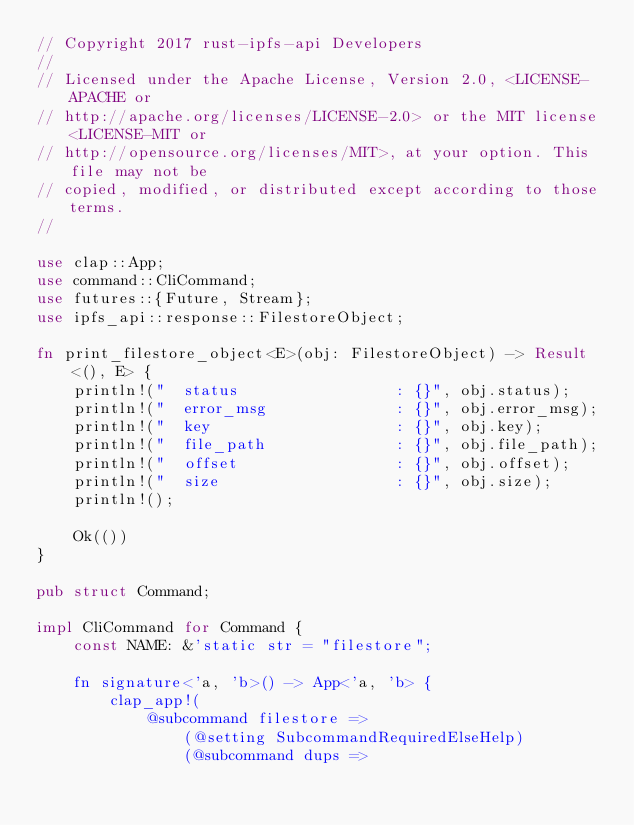Convert code to text. <code><loc_0><loc_0><loc_500><loc_500><_Rust_>// Copyright 2017 rust-ipfs-api Developers
//
// Licensed under the Apache License, Version 2.0, <LICENSE-APACHE or
// http://apache.org/licenses/LICENSE-2.0> or the MIT license <LICENSE-MIT or
// http://opensource.org/licenses/MIT>, at your option. This file may not be
// copied, modified, or distributed except according to those terms.
//

use clap::App;
use command::CliCommand;
use futures::{Future, Stream};
use ipfs_api::response::FilestoreObject;

fn print_filestore_object<E>(obj: FilestoreObject) -> Result<(), E> {
    println!("  status                 : {}", obj.status);
    println!("  error_msg              : {}", obj.error_msg);
    println!("  key                    : {}", obj.key);
    println!("  file_path              : {}", obj.file_path);
    println!("  offset                 : {}", obj.offset);
    println!("  size                   : {}", obj.size);
    println!();

    Ok(())
}

pub struct Command;

impl CliCommand for Command {
    const NAME: &'static str = "filestore";

    fn signature<'a, 'b>() -> App<'a, 'b> {
        clap_app!(
            @subcommand filestore =>
                (@setting SubcommandRequiredElseHelp)
                (@subcommand dups =></code> 